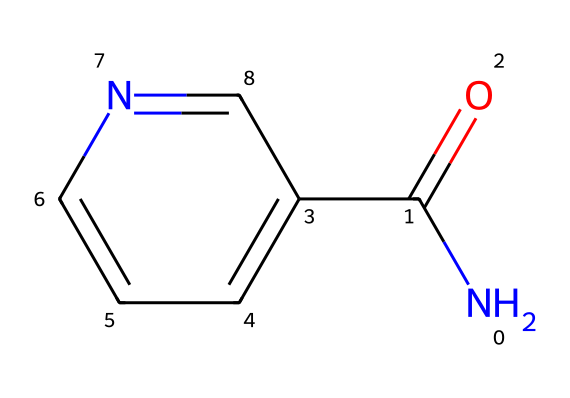How many nitrogen atoms are present in the molecular structure? The chemical structure includes a nitrogen atom (N) represented at the beginning of the SMILES code. By examining the representation, we can identify one nitrogen atom in the molecule.
Answer: 1 What type of functional group is present in niacinamide? The SMILES indicates the presence of an amide group (NC(=O)), where the nitrogen (N) is bonded to a carbonyl (C=O). Thus, this structure has an amide functional group.
Answer: amide How many carbon atoms are in the structure? By analyzing the structure, there are three distinct carbon atoms visible in the SMILES, including one in the carbonyl group and two in the aromatic ring. Therefore, the total count of carbon atoms is four.
Answer: 4 What is the primary effect of niacinamide in cosmetic formulations? Niacinamide is well-known for its ability to brighten skin and improve uneven skin tone, derived from its role as a skin-conditioning agent in cosmetic formulations. Thus, the primary effect is skin-brightening.
Answer: skin-brightening Does niacinamide have any aromatic properties? The structure features a benzene-like ring (c1cccnc1) that confirms the aromatic nature of part of the molecule, which contributes to various physical and chemical properties.
Answer: yes How does the structure of niacinamide contribute to its solubility? Niacinamide contains polar functional groups such as the amide and nitrogen, which enhance its solubility in water compared to non-polar compounds. Hence, the presence of these polar groups facilitates solubility.
Answer: polar groups 